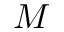Convert formula to latex. <formula><loc_0><loc_0><loc_500><loc_500>M</formula> 